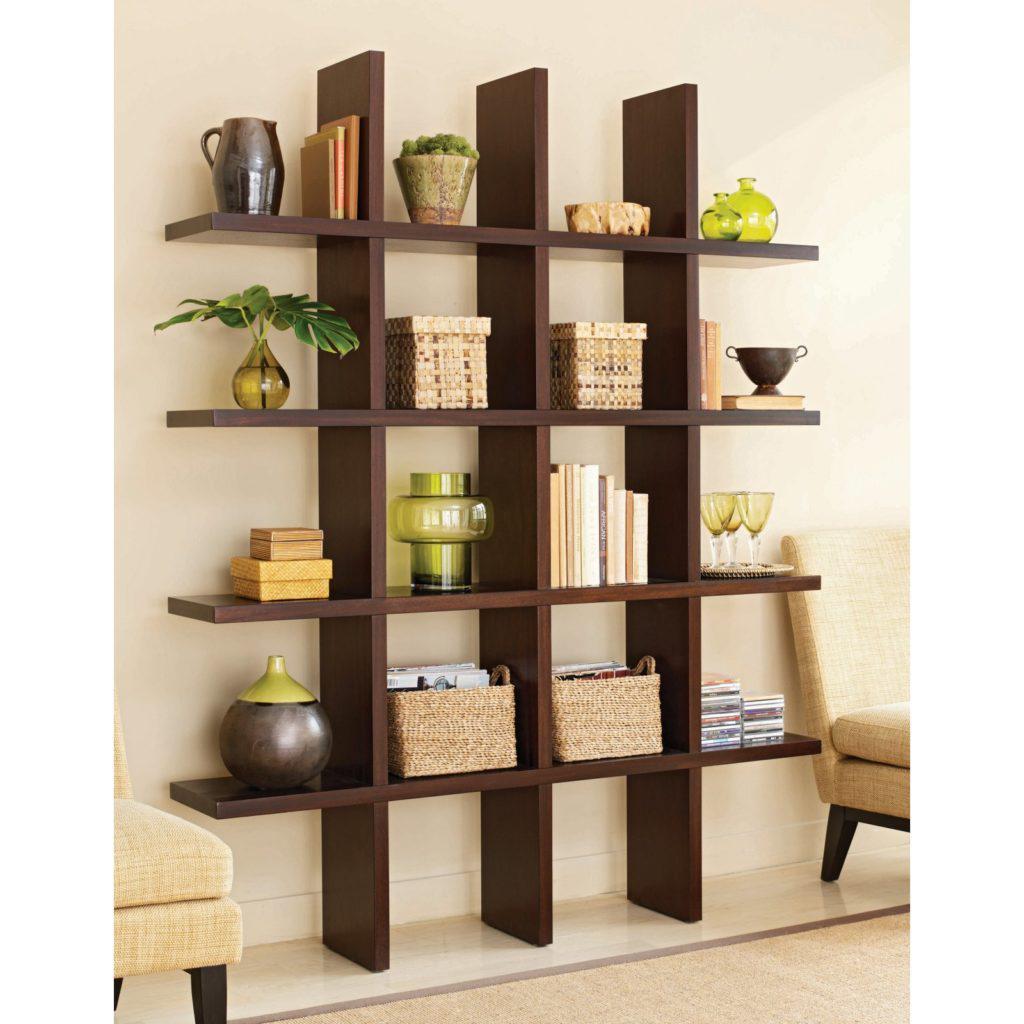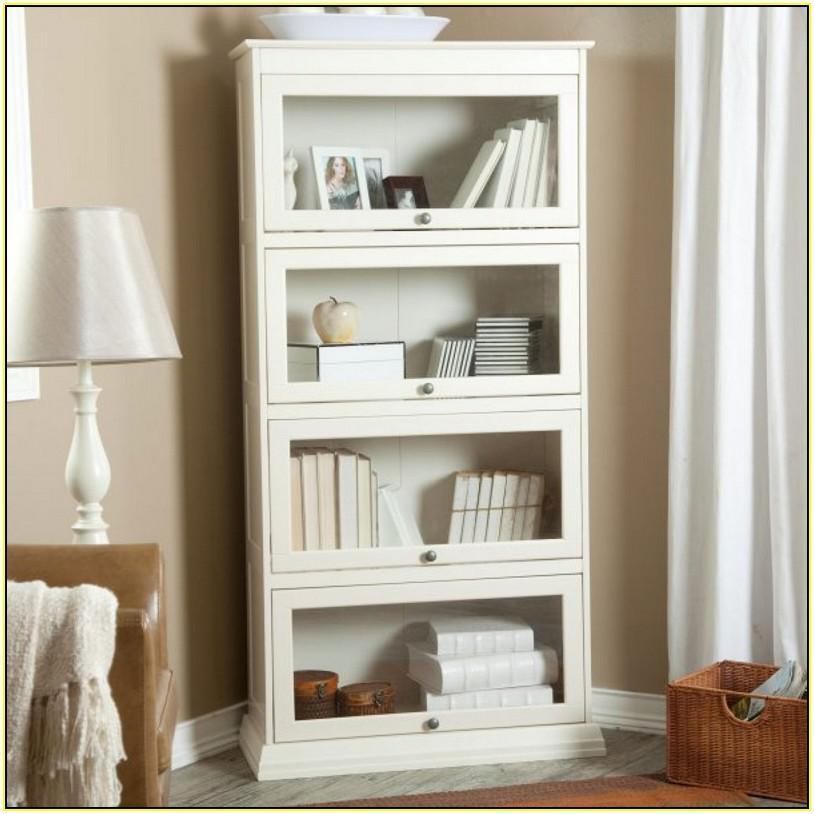The first image is the image on the left, the second image is the image on the right. Considering the images on both sides, is "One image features a backless, sideless style of shelf storage in brown wood, and the other image features more traditional styling with glass-fronted enclosed white cabinets." valid? Answer yes or no. Yes. The first image is the image on the left, the second image is the image on the right. For the images displayed, is the sentence "The shelves in the image on the left have no doors." factually correct? Answer yes or no. Yes. 